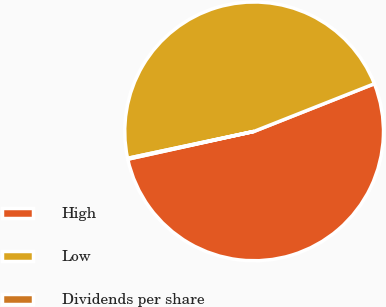Convert chart to OTSL. <chart><loc_0><loc_0><loc_500><loc_500><pie_chart><fcel>High<fcel>Low<fcel>Dividends per share<nl><fcel>52.55%<fcel>47.34%<fcel>0.11%<nl></chart> 